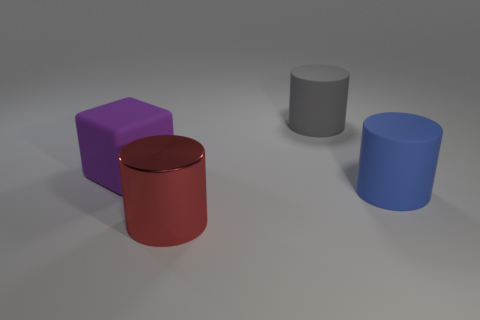Add 2 small brown metal blocks. How many objects exist? 6 Subtract all blocks. How many objects are left? 3 Subtract all small shiny things. Subtract all red cylinders. How many objects are left? 3 Add 1 large blue cylinders. How many large blue cylinders are left? 2 Add 4 big matte things. How many big matte things exist? 7 Subtract 1 gray cylinders. How many objects are left? 3 